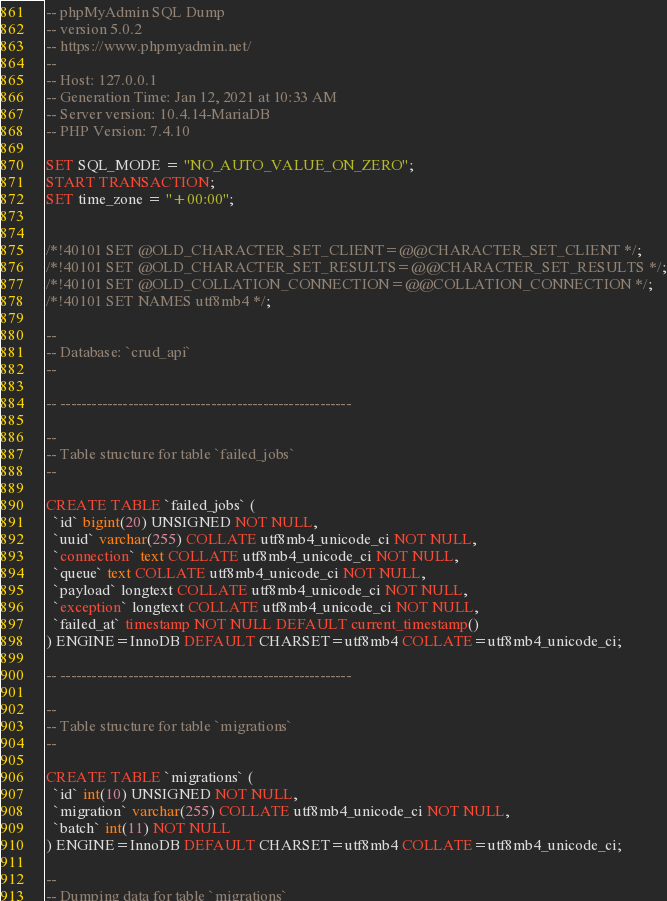Convert code to text. <code><loc_0><loc_0><loc_500><loc_500><_SQL_>-- phpMyAdmin SQL Dump
-- version 5.0.2
-- https://www.phpmyadmin.net/
--
-- Host: 127.0.0.1
-- Generation Time: Jan 12, 2021 at 10:33 AM
-- Server version: 10.4.14-MariaDB
-- PHP Version: 7.4.10

SET SQL_MODE = "NO_AUTO_VALUE_ON_ZERO";
START TRANSACTION;
SET time_zone = "+00:00";


/*!40101 SET @OLD_CHARACTER_SET_CLIENT=@@CHARACTER_SET_CLIENT */;
/*!40101 SET @OLD_CHARACTER_SET_RESULTS=@@CHARACTER_SET_RESULTS */;
/*!40101 SET @OLD_COLLATION_CONNECTION=@@COLLATION_CONNECTION */;
/*!40101 SET NAMES utf8mb4 */;

--
-- Database: `crud_api`
--

-- --------------------------------------------------------

--
-- Table structure for table `failed_jobs`
--

CREATE TABLE `failed_jobs` (
  `id` bigint(20) UNSIGNED NOT NULL,
  `uuid` varchar(255) COLLATE utf8mb4_unicode_ci NOT NULL,
  `connection` text COLLATE utf8mb4_unicode_ci NOT NULL,
  `queue` text COLLATE utf8mb4_unicode_ci NOT NULL,
  `payload` longtext COLLATE utf8mb4_unicode_ci NOT NULL,
  `exception` longtext COLLATE utf8mb4_unicode_ci NOT NULL,
  `failed_at` timestamp NOT NULL DEFAULT current_timestamp()
) ENGINE=InnoDB DEFAULT CHARSET=utf8mb4 COLLATE=utf8mb4_unicode_ci;

-- --------------------------------------------------------

--
-- Table structure for table `migrations`
--

CREATE TABLE `migrations` (
  `id` int(10) UNSIGNED NOT NULL,
  `migration` varchar(255) COLLATE utf8mb4_unicode_ci NOT NULL,
  `batch` int(11) NOT NULL
) ENGINE=InnoDB DEFAULT CHARSET=utf8mb4 COLLATE=utf8mb4_unicode_ci;

--
-- Dumping data for table `migrations`</code> 